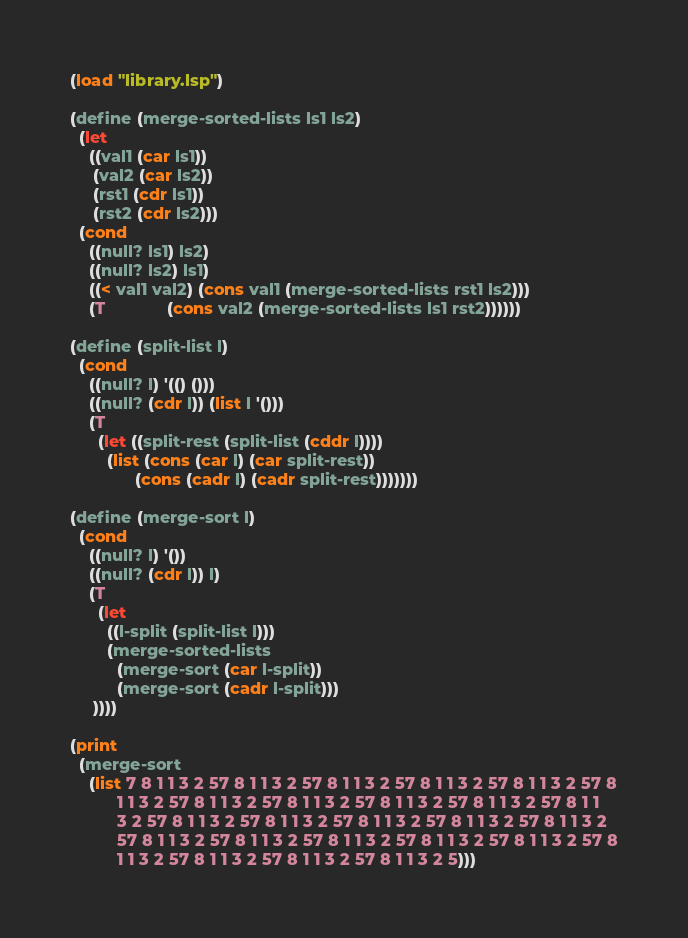<code> <loc_0><loc_0><loc_500><loc_500><_Lisp_>(load "library.lsp")

(define (merge-sorted-lists ls1 ls2)
  (let
    ((val1 (car ls1))
     (val2 (car ls2))
     (rst1 (cdr ls1))
     (rst2 (cdr ls2)))
  (cond
    ((null? ls1) ls2)
    ((null? ls2) ls1)
    ((< val1 val2) (cons val1 (merge-sorted-lists rst1 ls2)))
    (T             (cons val2 (merge-sorted-lists ls1 rst2))))))

(define (split-list l)
  (cond
    ((null? l) '(() ()))
    ((null? (cdr l)) (list l '()))
    (T
      (let ((split-rest (split-list (cddr l))))
        (list (cons (car l) (car split-rest))
              (cons (cadr l) (cadr split-rest)))))))

(define (merge-sort l)
  (cond
    ((null? l) '())
    ((null? (cdr l)) l)
    (T
      (let
        ((l-split (split-list l)))
        (merge-sorted-lists
          (merge-sort (car l-split))
          (merge-sort (cadr l-split)))
     ))))

(print
  (merge-sort
    (list 7 8 1 1 3 2 57 8 1 1 3 2 57 8 1 1 3 2 57 8 1 1 3 2 57 8 1 1 3 2 57 8
          1 1 3 2 57 8 1 1 3 2 57 8 1 1 3 2 57 8 1 1 3 2 57 8 1 1 3 2 57 8 1 1
          3 2 57 8 1 1 3 2 57 8 1 1 3 2 57 8 1 1 3 2 57 8 1 1 3 2 57 8 1 1 3 2
          57 8 1 1 3 2 57 8 1 1 3 2 57 8 1 1 3 2 57 8 1 1 3 2 57 8 1 1 3 2 57 8
          1 1 3 2 57 8 1 1 3 2 57 8 1 1 3 2 57 8 1 1 3 2 5)))
</code> 